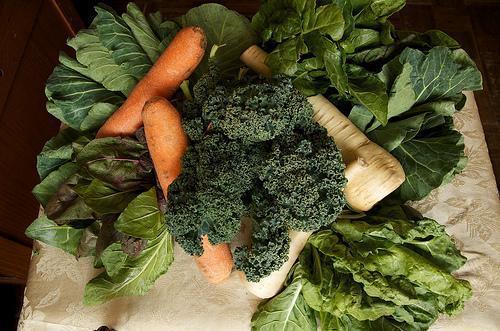How many carrots are there?
Give a very brief answer. 2. How many kinds of root vegetables are there?
Give a very brief answer. 2. 